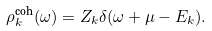Convert formula to latex. <formula><loc_0><loc_0><loc_500><loc_500>\rho ^ { \text {coh} } _ { k } ( \omega ) = Z _ { k } \delta ( \omega + \mu - E _ { k } ) .</formula> 